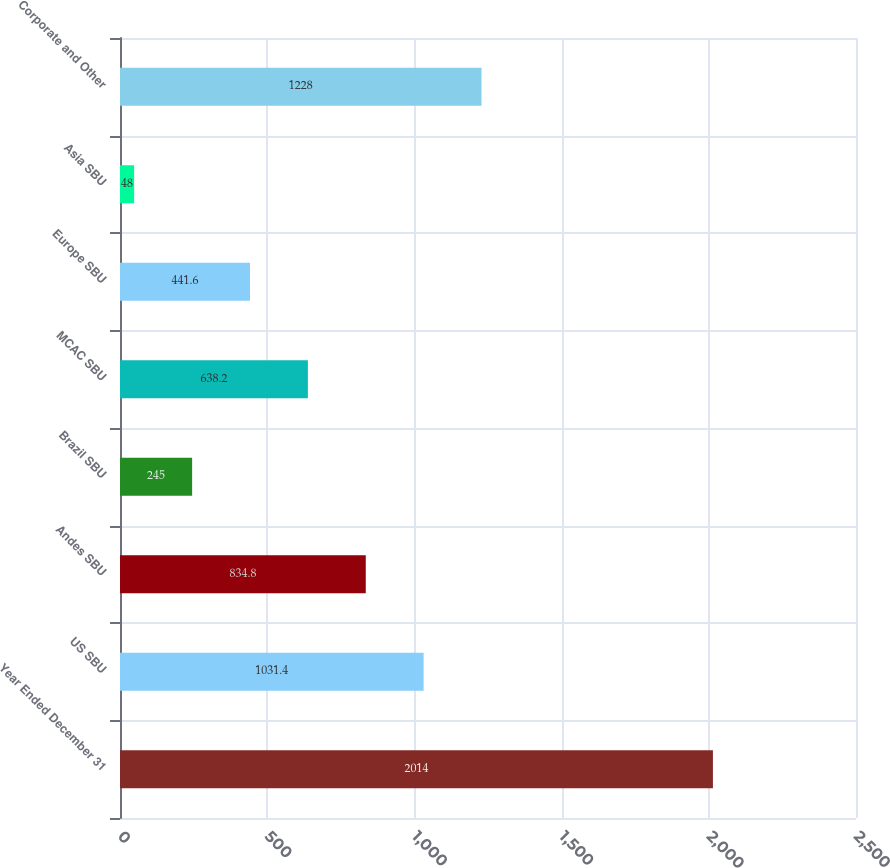<chart> <loc_0><loc_0><loc_500><loc_500><bar_chart><fcel>Year Ended December 31<fcel>US SBU<fcel>Andes SBU<fcel>Brazil SBU<fcel>MCAC SBU<fcel>Europe SBU<fcel>Asia SBU<fcel>Corporate and Other<nl><fcel>2014<fcel>1031.4<fcel>834.8<fcel>245<fcel>638.2<fcel>441.6<fcel>48<fcel>1228<nl></chart> 